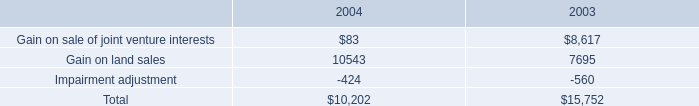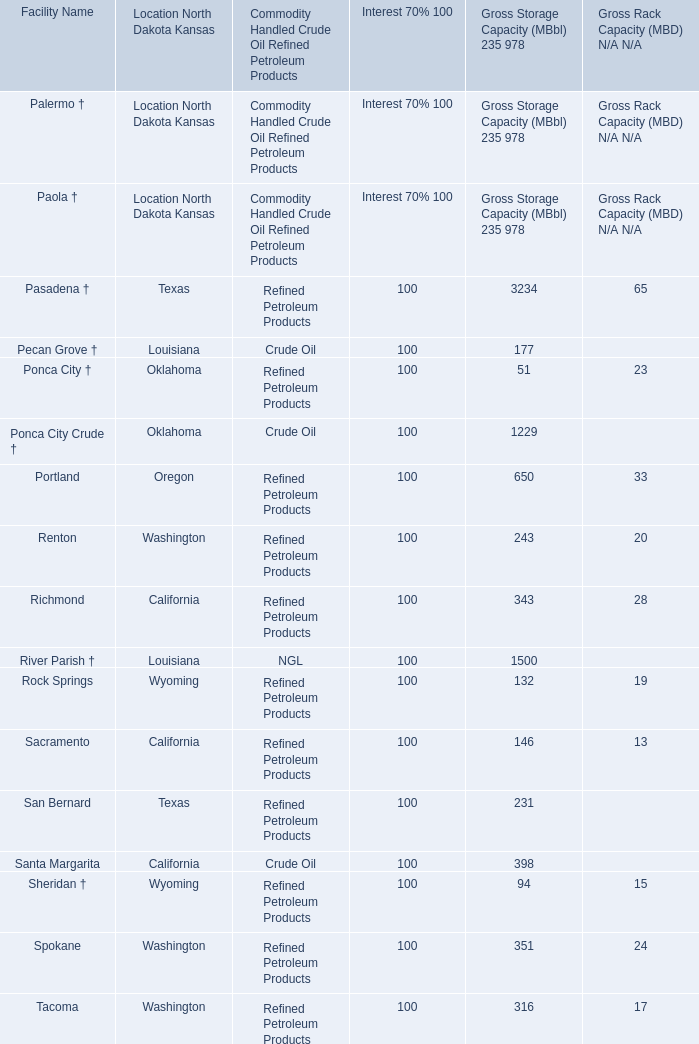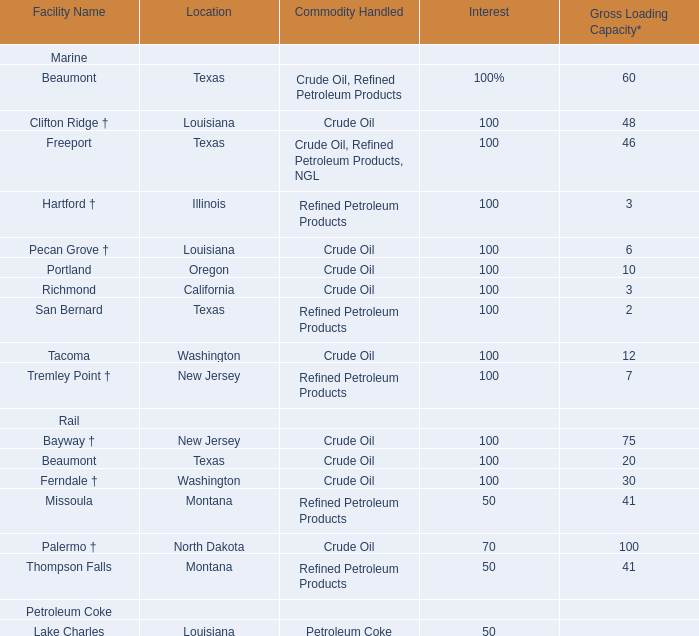in 2004 what was the ratio of the increase in the depreciation expense on the tenant improvement to the buildings 
Computations: (14.1 / 6)
Answer: 2.35. 